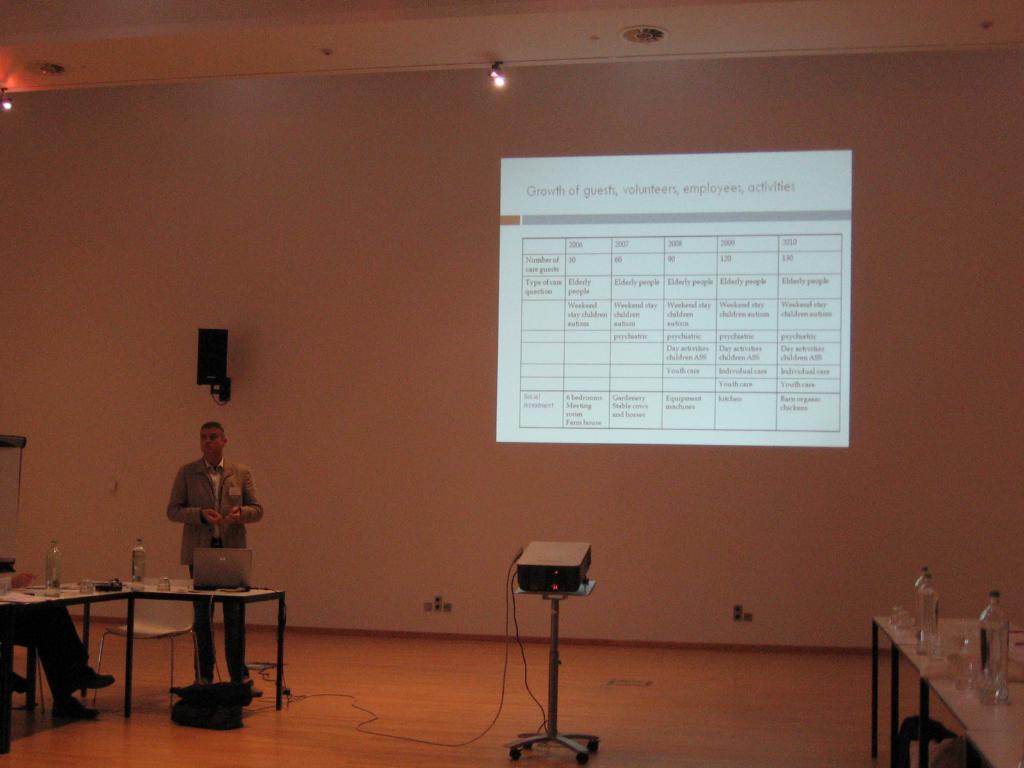Can you describe this image briefly? In this image I see a man over here who is standing and I see tables on which there are bottles and I see a person who is sitting on a chair and I see a chair over here and I see the stand on which there is a projector and I see the projector screen over here and I see the floor and I see a black color thing over here and I see the wires and I see the lights on the ceiling. 